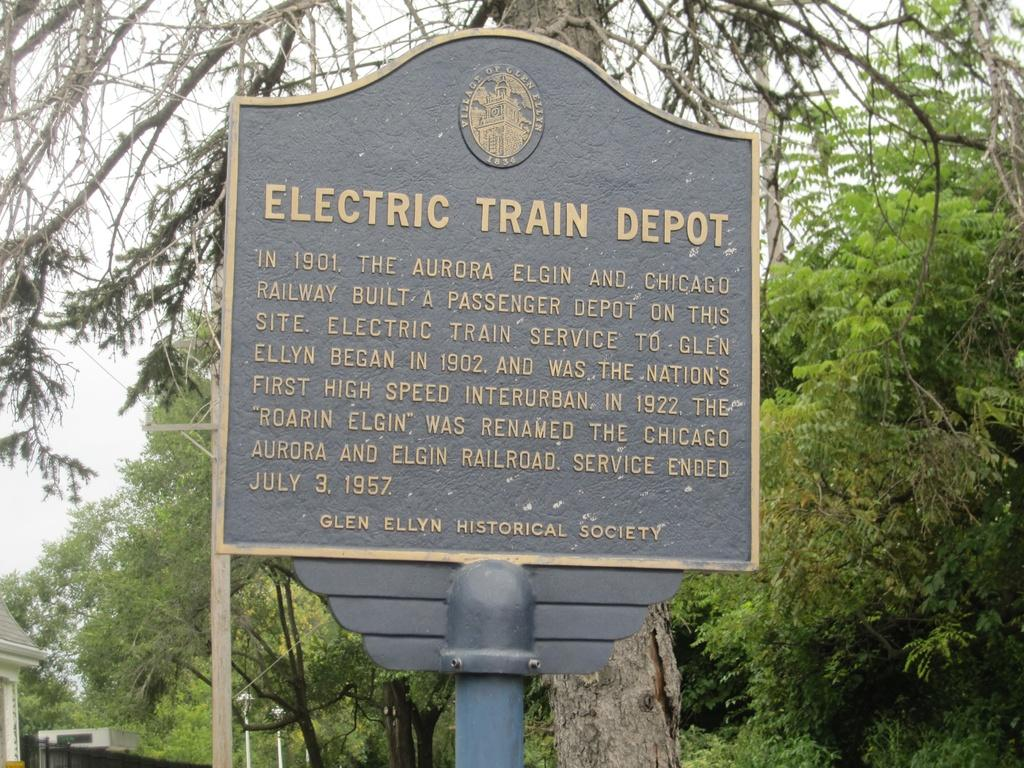What is the main object in the image with a pole attached to it? There is a board with a pole in the image. What can be found on the board? There is a logo and words on the board. What type of natural elements are present in the image? There are trees in the image. How many poles can be seen in the image? There are poles in the image. What type of structures are visible in the image? There are buildings in the image. What can be seen in the background of the image? The sky is visible in the background of the image. What type of wax is being used to coat the road in the image? There is no road or wax present in the image; it features a board with a pole, trees, buildings, and the sky. How many units are visible in the image? The term "unit" is not mentioned or relevant to the image, as it features a board with a pole, trees, buildings, and the sky. 